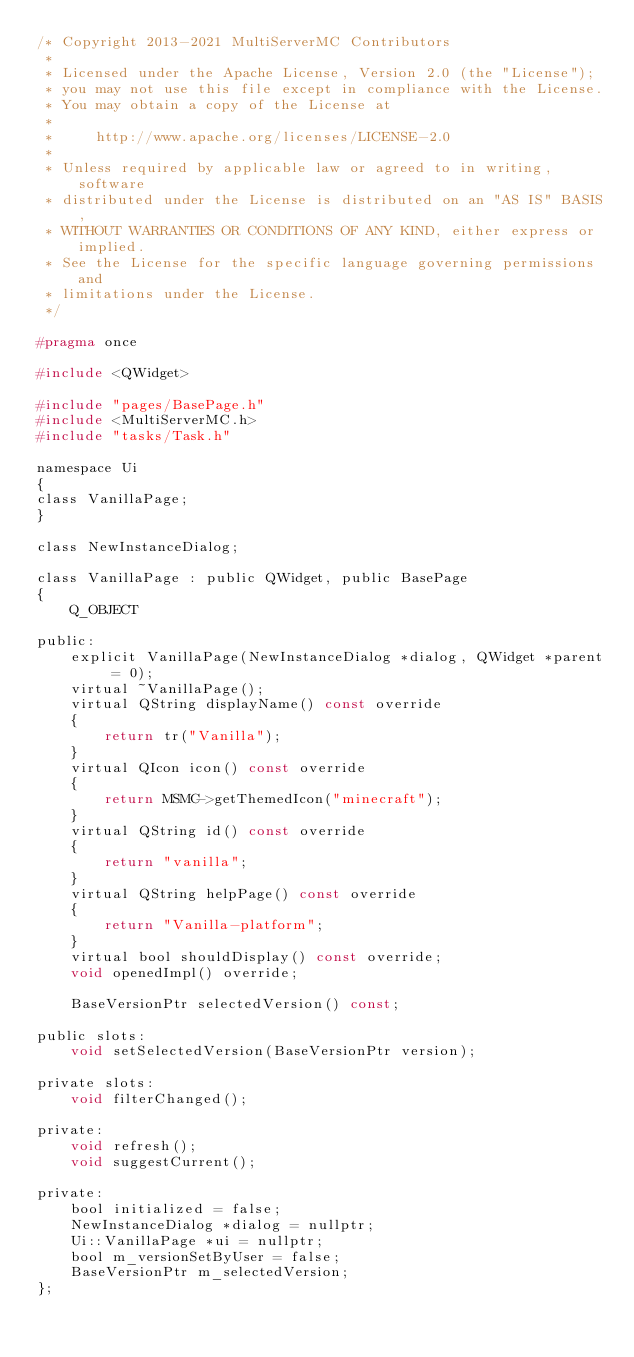<code> <loc_0><loc_0><loc_500><loc_500><_C_>/* Copyright 2013-2021 MultiServerMC Contributors
 *
 * Licensed under the Apache License, Version 2.0 (the "License");
 * you may not use this file except in compliance with the License.
 * You may obtain a copy of the License at
 *
 *     http://www.apache.org/licenses/LICENSE-2.0
 *
 * Unless required by applicable law or agreed to in writing, software
 * distributed under the License is distributed on an "AS IS" BASIS,
 * WITHOUT WARRANTIES OR CONDITIONS OF ANY KIND, either express or implied.
 * See the License for the specific language governing permissions and
 * limitations under the License.
 */

#pragma once

#include <QWidget>

#include "pages/BasePage.h"
#include <MultiServerMC.h>
#include "tasks/Task.h"

namespace Ui
{
class VanillaPage;
}

class NewInstanceDialog;

class VanillaPage : public QWidget, public BasePage
{
    Q_OBJECT

public:
    explicit VanillaPage(NewInstanceDialog *dialog, QWidget *parent = 0);
    virtual ~VanillaPage();
    virtual QString displayName() const override
    {
        return tr("Vanilla");
    }
    virtual QIcon icon() const override
    {
        return MSMC->getThemedIcon("minecraft");
    }
    virtual QString id() const override
    {
        return "vanilla";
    }
    virtual QString helpPage() const override
    {
        return "Vanilla-platform";
    }
    virtual bool shouldDisplay() const override;
    void openedImpl() override;

    BaseVersionPtr selectedVersion() const;

public slots:
    void setSelectedVersion(BaseVersionPtr version);

private slots:
    void filterChanged();

private:
    void refresh();
    void suggestCurrent();

private:
    bool initialized = false;
    NewInstanceDialog *dialog = nullptr;
    Ui::VanillaPage *ui = nullptr;
    bool m_versionSetByUser = false;
    BaseVersionPtr m_selectedVersion;
};
</code> 